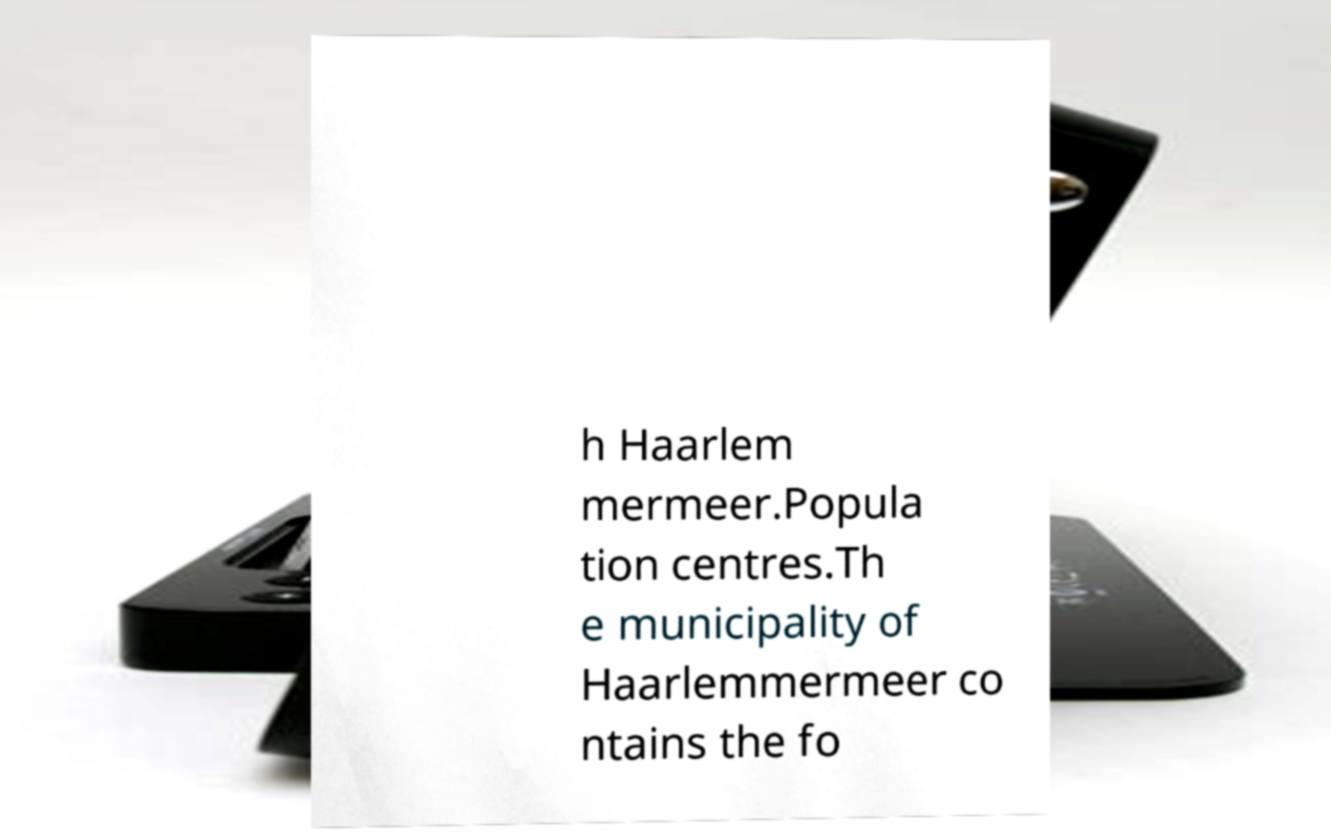What messages or text are displayed in this image? I need them in a readable, typed format. h Haarlem mermeer.Popula tion centres.Th e municipality of Haarlemmermeer co ntains the fo 